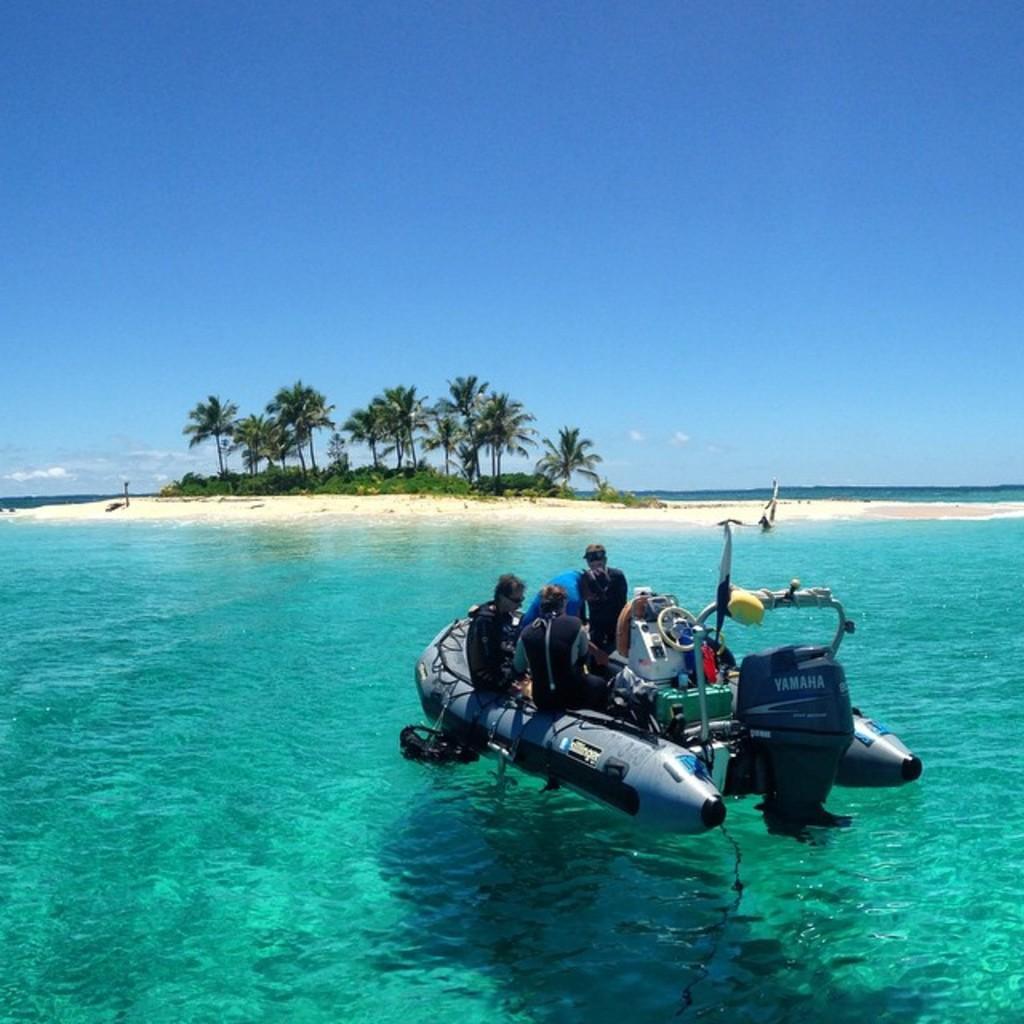Please provide a concise description of this image. In this image we can see these persons are sitting on the inflatable boat which is floating on the water. In the background, we can see sand, trees and sky with clouds. 